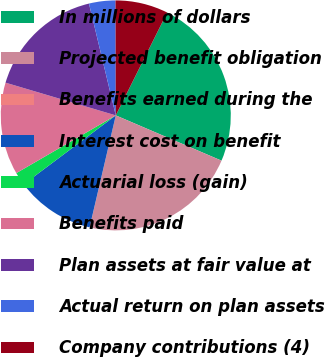<chart> <loc_0><loc_0><loc_500><loc_500><pie_chart><fcel>In millions of dollars<fcel>Projected benefit obligation<fcel>Benefits earned during the<fcel>Interest cost on benefit<fcel>Actuarial loss (gain)<fcel>Benefits paid<fcel>Plan assets at fair value at<fcel>Actual return on plan assets<fcel>Company contributions (4)<nl><fcel>24.06%<fcel>22.21%<fcel>0.01%<fcel>11.11%<fcel>1.86%<fcel>12.96%<fcel>16.66%<fcel>3.71%<fcel>7.41%<nl></chart> 